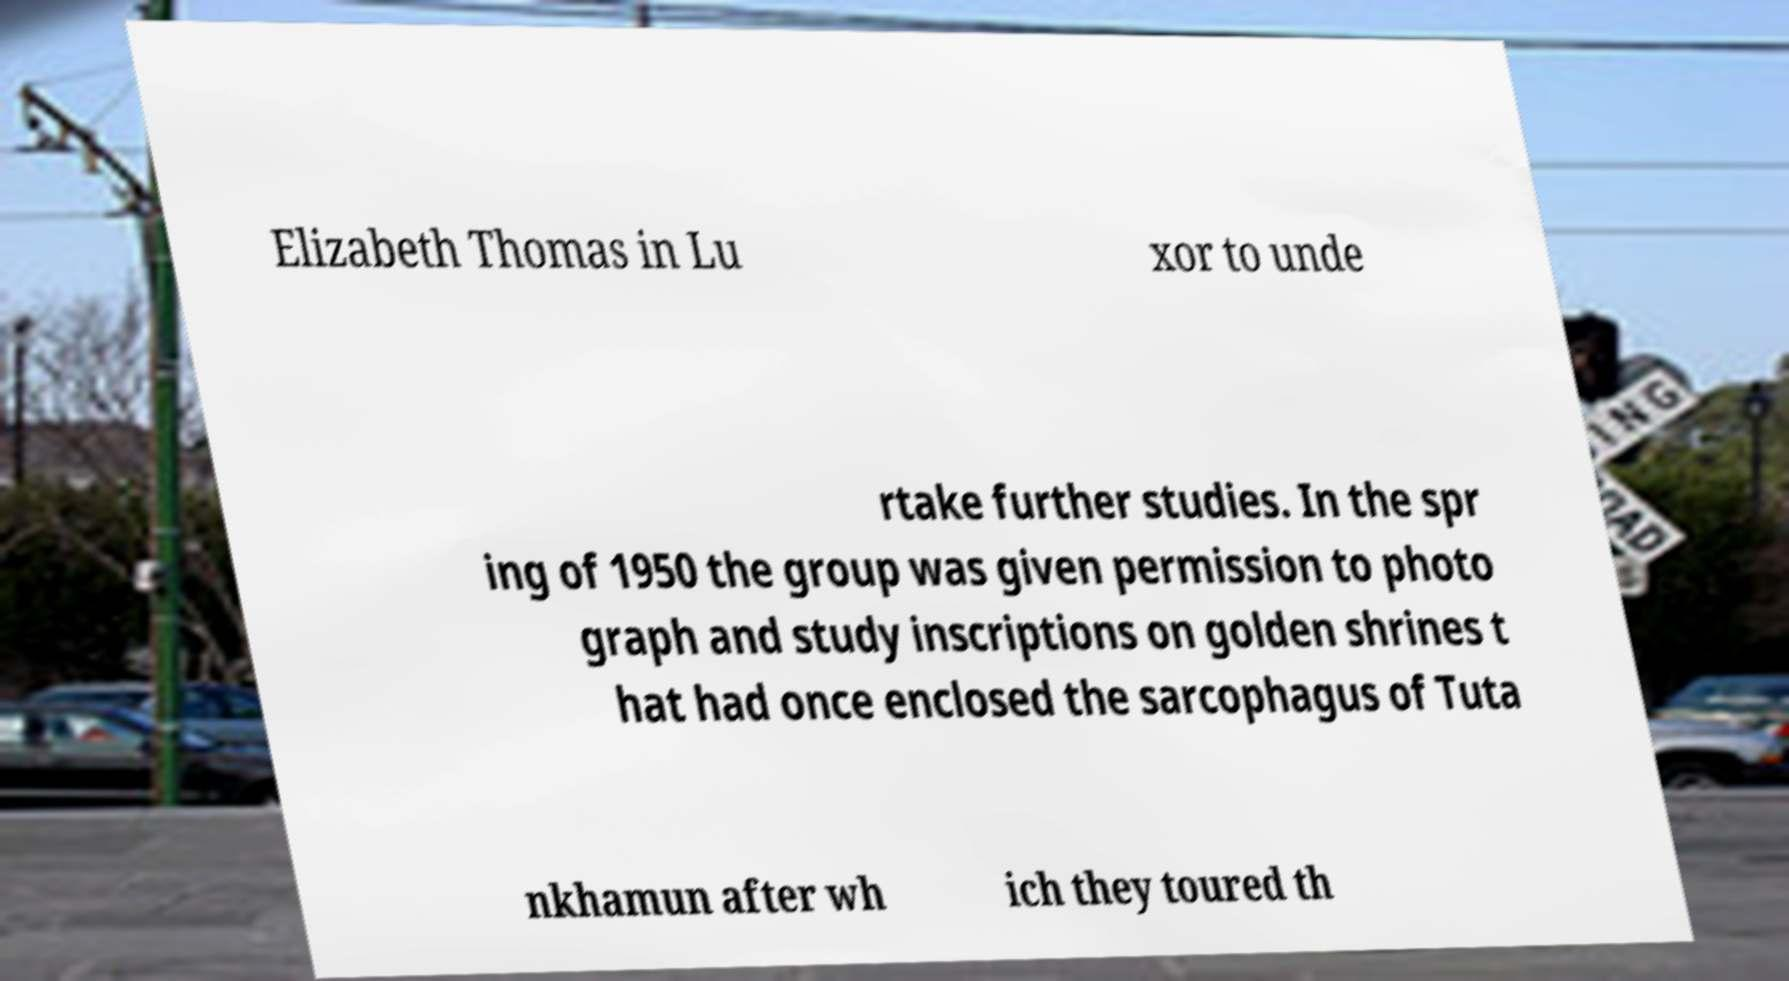Please identify and transcribe the text found in this image. Elizabeth Thomas in Lu xor to unde rtake further studies. In the spr ing of 1950 the group was given permission to photo graph and study inscriptions on golden shrines t hat had once enclosed the sarcophagus of Tuta nkhamun after wh ich they toured th 